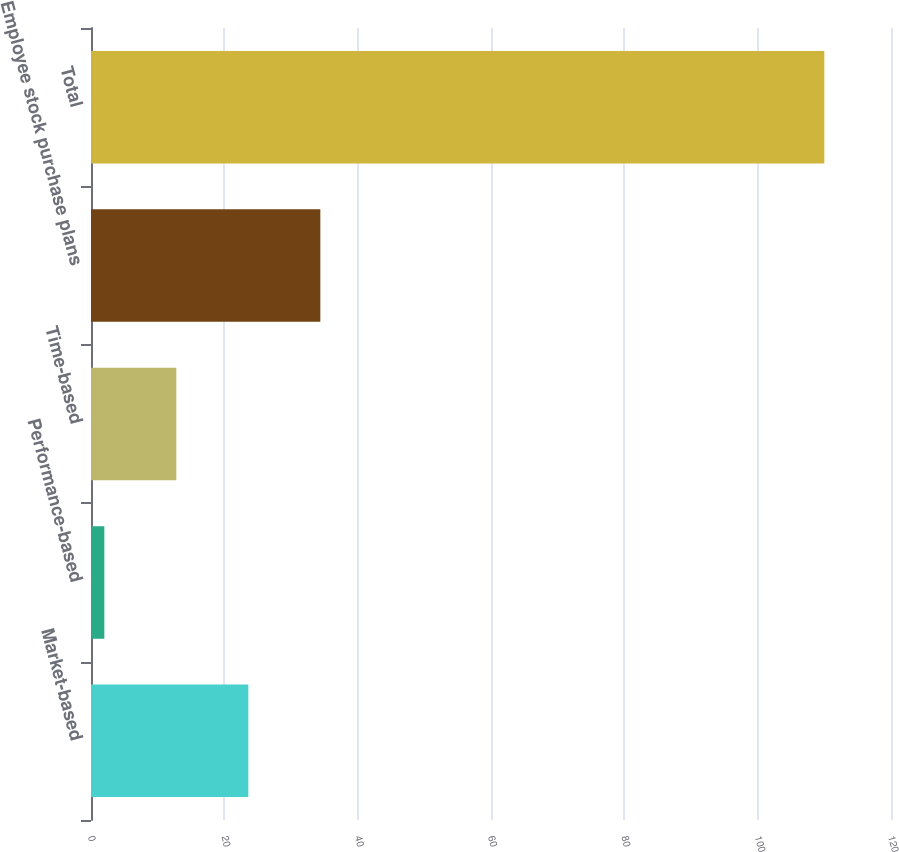<chart> <loc_0><loc_0><loc_500><loc_500><bar_chart><fcel>Market-based<fcel>Performance-based<fcel>Time-based<fcel>Employee stock purchase plans<fcel>Total<nl><fcel>23.6<fcel>2<fcel>12.8<fcel>34.4<fcel>110<nl></chart> 